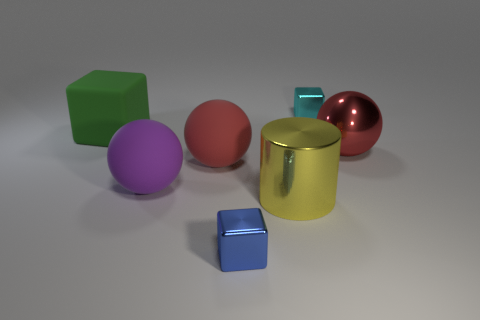Are there any other things that have the same shape as the big yellow metallic object?
Offer a very short reply. No. There is a thing that is both behind the big red metal sphere and left of the tiny blue metallic thing; what color is it?
Your answer should be compact. Green. The cylinder has what size?
Your answer should be compact. Large. What number of purple matte objects have the same size as the matte cube?
Provide a short and direct response. 1. Are the red object that is right of the big cylinder and the tiny cube that is on the left side of the cyan cube made of the same material?
Keep it short and to the point. Yes. There is a big thing that is behind the red sphere that is on the right side of the cyan metallic cube; what is it made of?
Ensure brevity in your answer.  Rubber. What material is the yellow thing that is on the right side of the green rubber block?
Offer a very short reply. Metal. What number of green rubber things are the same shape as the small blue thing?
Provide a succinct answer. 1. Is the color of the big metal cylinder the same as the large rubber cube?
Your answer should be compact. No. What is the material of the ball left of the red object left of the big metallic object that is behind the purple matte object?
Your answer should be compact. Rubber. 